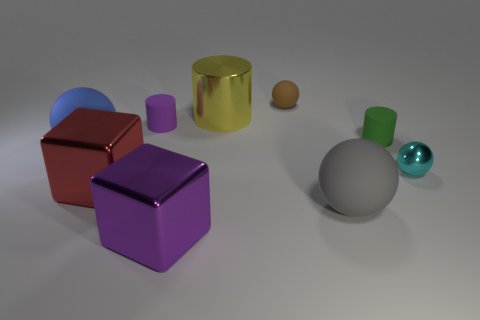Can you tell me the color of the object that resembles a bottle? The object resembling a bottle appears to be green with a slightly translucent quality, suggestive of glass or a similar material. 